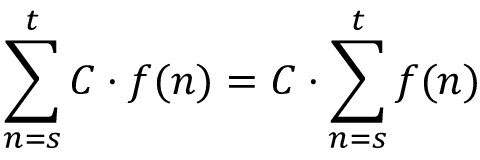Convert formula to latex. <formula><loc_0><loc_0><loc_500><loc_500>\sum _ { n = s } ^ { t } C \cdot f ( n ) = C \cdot \sum _ { n = s } ^ { t } f ( n )</formula> 